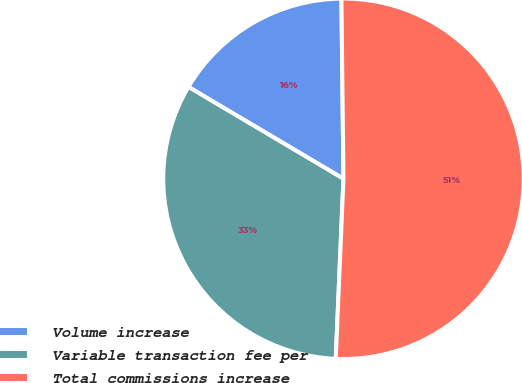Convert chart. <chart><loc_0><loc_0><loc_500><loc_500><pie_chart><fcel>Volume increase<fcel>Variable transaction fee per<fcel>Total commissions increase<nl><fcel>16.31%<fcel>32.83%<fcel>50.86%<nl></chart> 